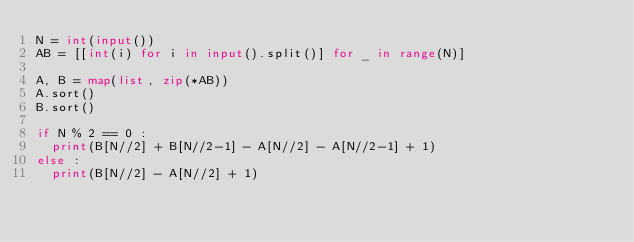Convert code to text. <code><loc_0><loc_0><loc_500><loc_500><_Python_>N = int(input())
AB = [[int(i) for i in input().split()] for _ in range(N)]

A, B = map(list, zip(*AB))
A.sort()
B.sort()

if N % 2 == 0 :
  print(B[N//2] + B[N//2-1] - A[N//2] - A[N//2-1] + 1)
else :
  print(B[N//2] - A[N//2] + 1)</code> 